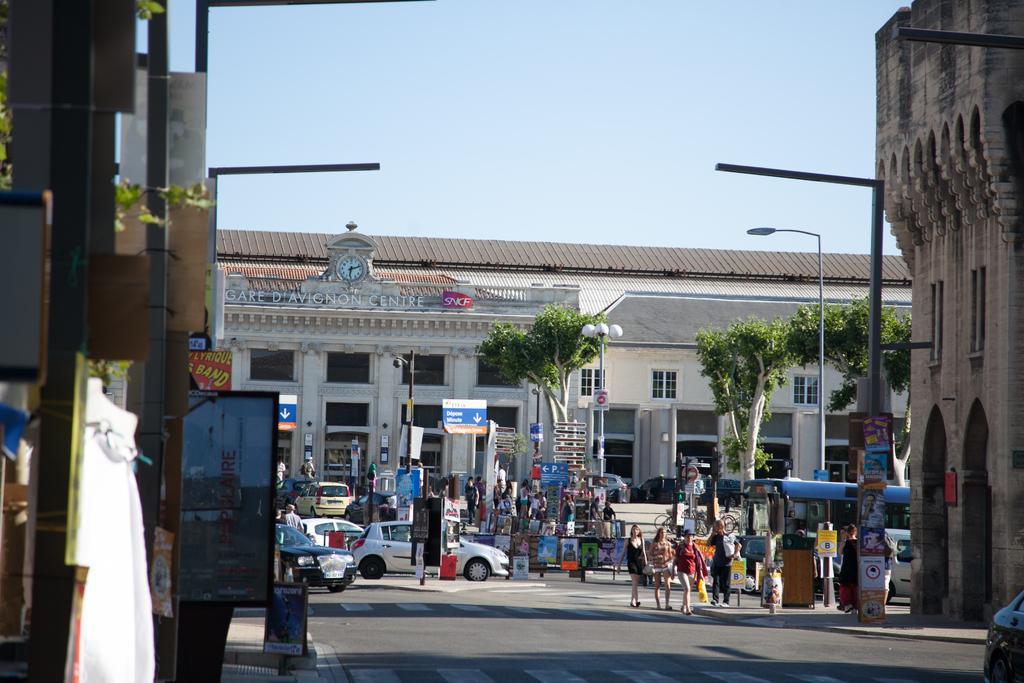Describe this image in one or two sentences. In this image, there are vehicles, people, poles, boards, banners, buildings, walls, street lights, windows, roads, walkways, clock and some objects. At the top of the image, there is the sky. 